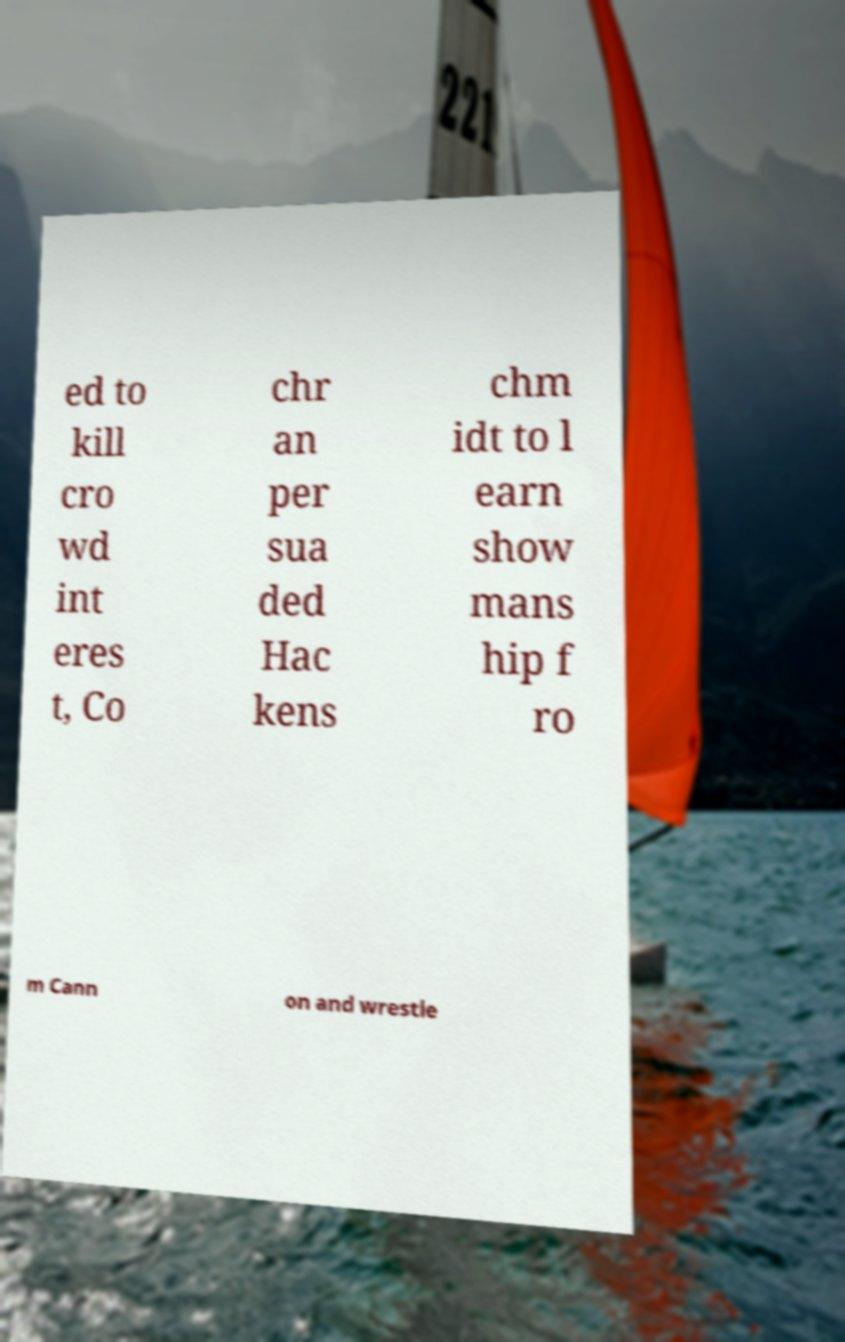What messages or text are displayed in this image? I need them in a readable, typed format. ed to kill cro wd int eres t, Co chr an per sua ded Hac kens chm idt to l earn show mans hip f ro m Cann on and wrestle 